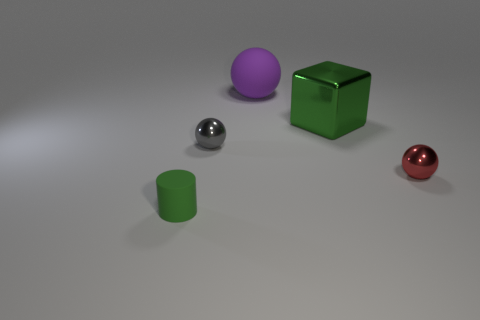Add 2 big brown shiny cubes. How many objects exist? 7 Subtract all cylinders. How many objects are left? 4 Add 4 gray shiny balls. How many gray shiny balls are left? 5 Add 5 tiny gray objects. How many tiny gray objects exist? 6 Subtract 0 red blocks. How many objects are left? 5 Subtract all matte cylinders. Subtract all green rubber cylinders. How many objects are left? 3 